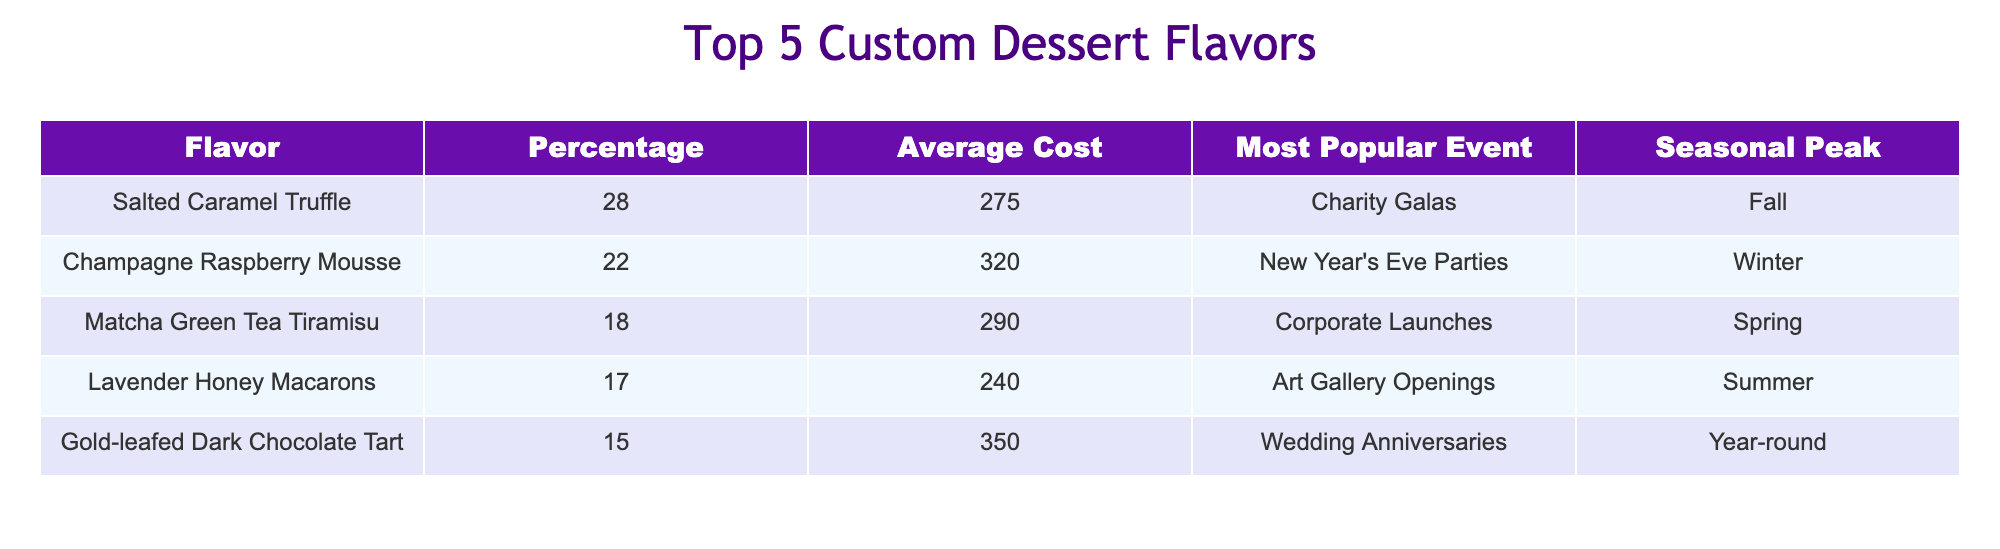Which dessert flavor has the highest percentage of orders? The table lists the flavors and their corresponding percentages. By comparing the percentages, Salted Caramel Truffle, with 28%, is the highest.
Answer: Salted Caramel Truffle What is the average cost of Champagne Raspberry Mousse? The table provides the cost, which is clearly listed as 320.
Answer: 320 Which dessert was most popular at New Year's Eve Parties? According to the table, Champagne Raspberry Mousse is noted as the most popular for New Year's Eve Parties.
Answer: Champagne Raspberry Mousse What is the total percentage of the top two dessert flavors? The percentages of the top two flavors are Salted Caramel Truffle (28) and Champagne Raspberry Mousse (22). Adding these gives 28 + 22 = 50%.
Answer: 50 Is Lavender Honey Macarons a summer dessert? The table indicates that Lavender Honey Macarons has a seasonal peak during summer, confirming it is indeed associated with that season.
Answer: Yes Which dessert has the highest average cost and what is that cost? The table shows Gold-leafed Dark Chocolate Tart with the highest cost of 350. Therefore, it has the highest average cost.
Answer: 350 What dessert flavor is most popular during Spring? Looking at the table, the Matcha Green Tea Tiramisu is indicated as the most popular during Spring.
Answer: Matcha Green Tea Tiramisu How much more expensive is the Gold-leafed Dark Chocolate Tart than the Lavender Honey Macarons? The table lists Gold-leafed Dark Chocolate Tart at 350 and Lavender Honey Macarons at 240. The difference is calculated as 350 - 240 = 110.
Answer: 110 What is the seasonal peak for Matcha Green Tea Tiramisu? The table specifies that Matcha Green Tea Tiramisu peaks in Spring.
Answer: Spring 